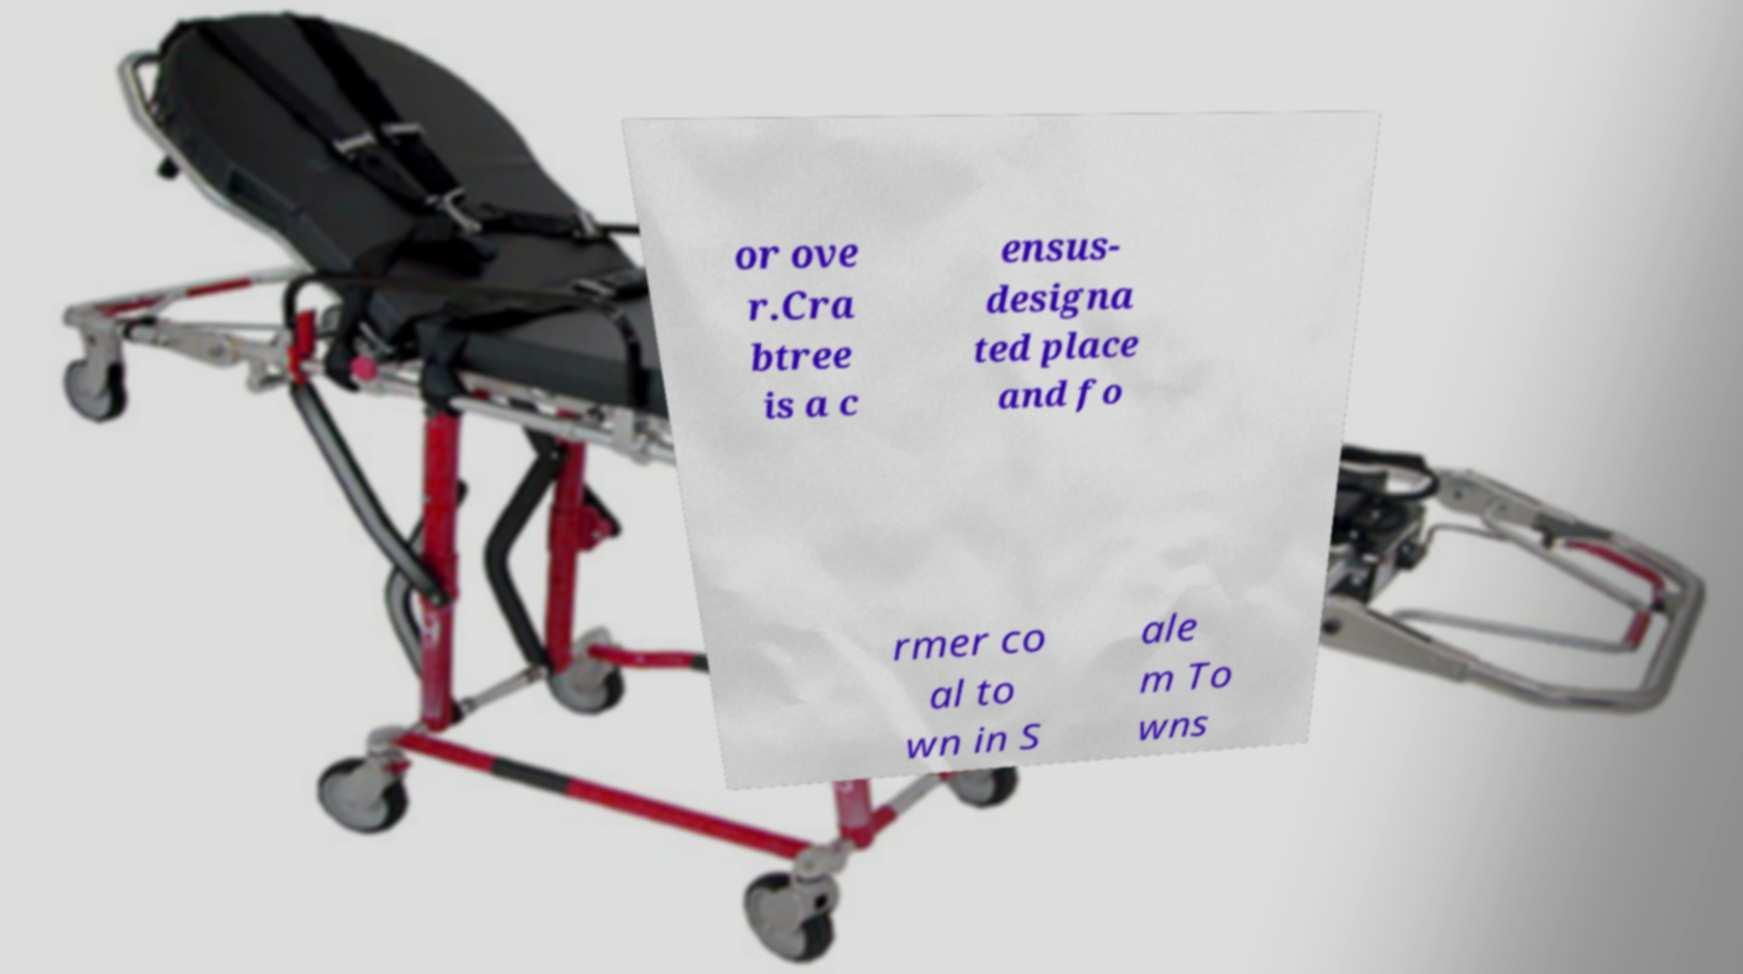What messages or text are displayed in this image? I need them in a readable, typed format. or ove r.Cra btree is a c ensus- designa ted place and fo rmer co al to wn in S ale m To wns 